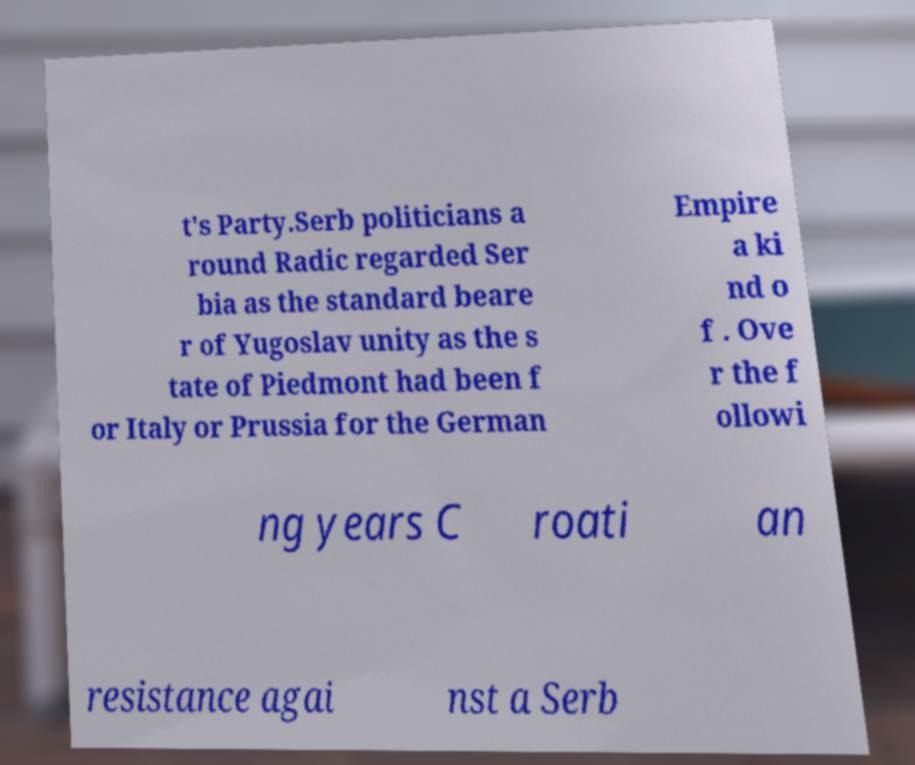Please identify and transcribe the text found in this image. t's Party.Serb politicians a round Radic regarded Ser bia as the standard beare r of Yugoslav unity as the s tate of Piedmont had been f or Italy or Prussia for the German Empire a ki nd o f . Ove r the f ollowi ng years C roati an resistance agai nst a Serb 